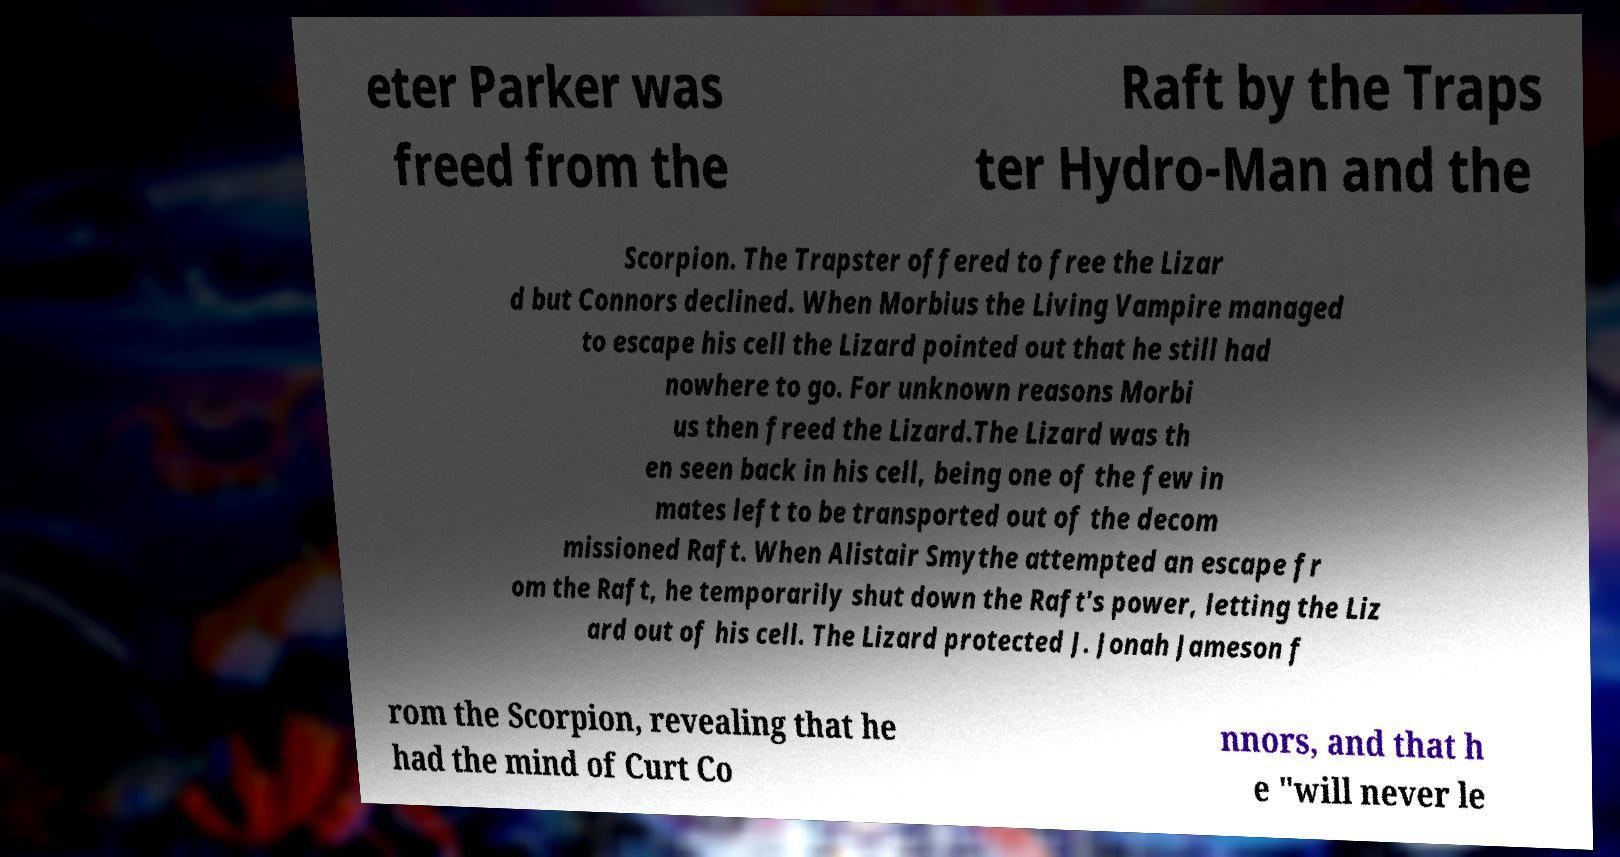What messages or text are displayed in this image? I need them in a readable, typed format. eter Parker was freed from the Raft by the Traps ter Hydro-Man and the Scorpion. The Trapster offered to free the Lizar d but Connors declined. When Morbius the Living Vampire managed to escape his cell the Lizard pointed out that he still had nowhere to go. For unknown reasons Morbi us then freed the Lizard.The Lizard was th en seen back in his cell, being one of the few in mates left to be transported out of the decom missioned Raft. When Alistair Smythe attempted an escape fr om the Raft, he temporarily shut down the Raft's power, letting the Liz ard out of his cell. The Lizard protected J. Jonah Jameson f rom the Scorpion, revealing that he had the mind of Curt Co nnors, and that h e "will never le 